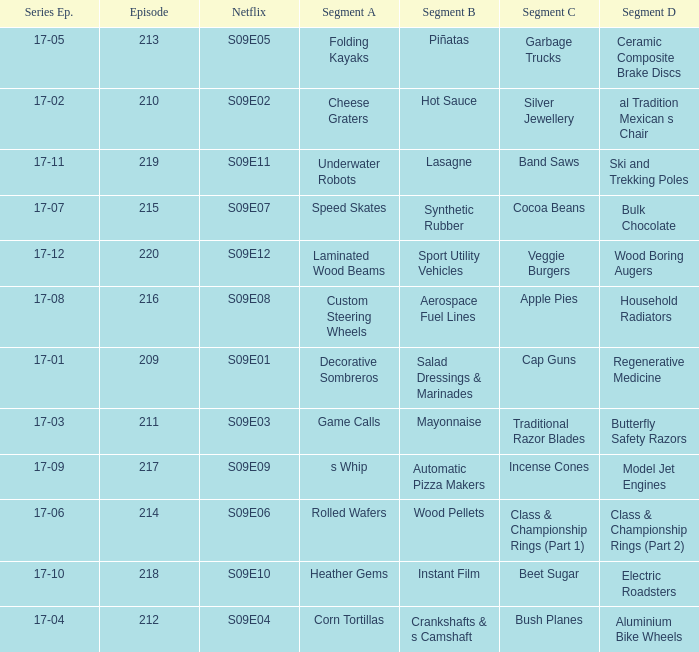For the shows featuring beet sugar, what was on before that Instant Film. 